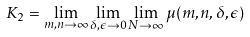Convert formula to latex. <formula><loc_0><loc_0><loc_500><loc_500>K _ { 2 } = \lim _ { m , n \rightarrow \infty } \lim _ { \delta , \epsilon \rightarrow 0 } \lim _ { N \rightarrow \infty } \mu ( m , n , \delta , \epsilon )</formula> 